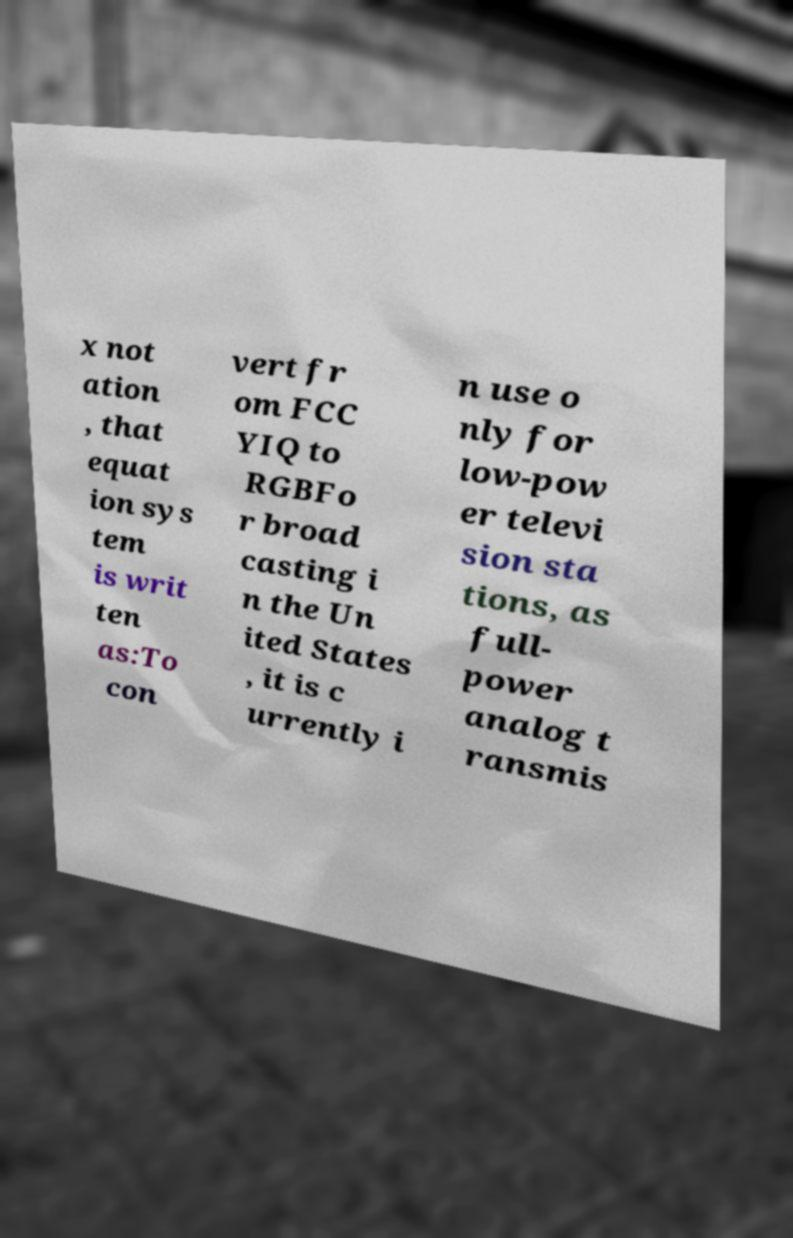I need the written content from this picture converted into text. Can you do that? x not ation , that equat ion sys tem is writ ten as:To con vert fr om FCC YIQ to RGBFo r broad casting i n the Un ited States , it is c urrently i n use o nly for low-pow er televi sion sta tions, as full- power analog t ransmis 